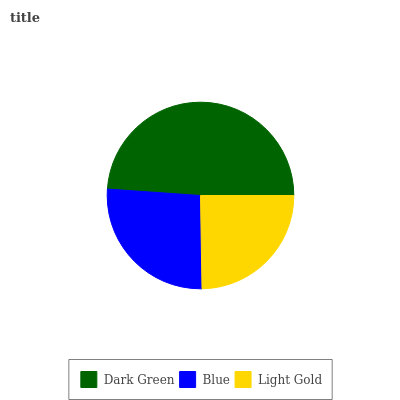Is Light Gold the minimum?
Answer yes or no. Yes. Is Dark Green the maximum?
Answer yes or no. Yes. Is Blue the minimum?
Answer yes or no. No. Is Blue the maximum?
Answer yes or no. No. Is Dark Green greater than Blue?
Answer yes or no. Yes. Is Blue less than Dark Green?
Answer yes or no. Yes. Is Blue greater than Dark Green?
Answer yes or no. No. Is Dark Green less than Blue?
Answer yes or no. No. Is Blue the high median?
Answer yes or no. Yes. Is Blue the low median?
Answer yes or no. Yes. Is Light Gold the high median?
Answer yes or no. No. Is Light Gold the low median?
Answer yes or no. No. 